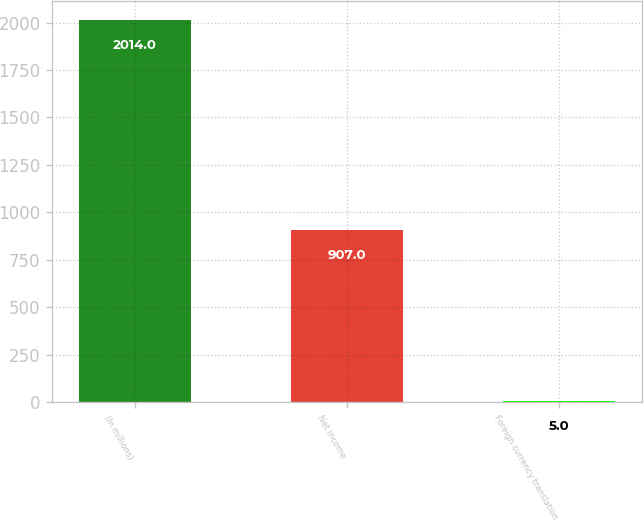Convert chart to OTSL. <chart><loc_0><loc_0><loc_500><loc_500><bar_chart><fcel>(In millions)<fcel>Net income<fcel>Foreign currency translation<nl><fcel>2014<fcel>907<fcel>5<nl></chart> 